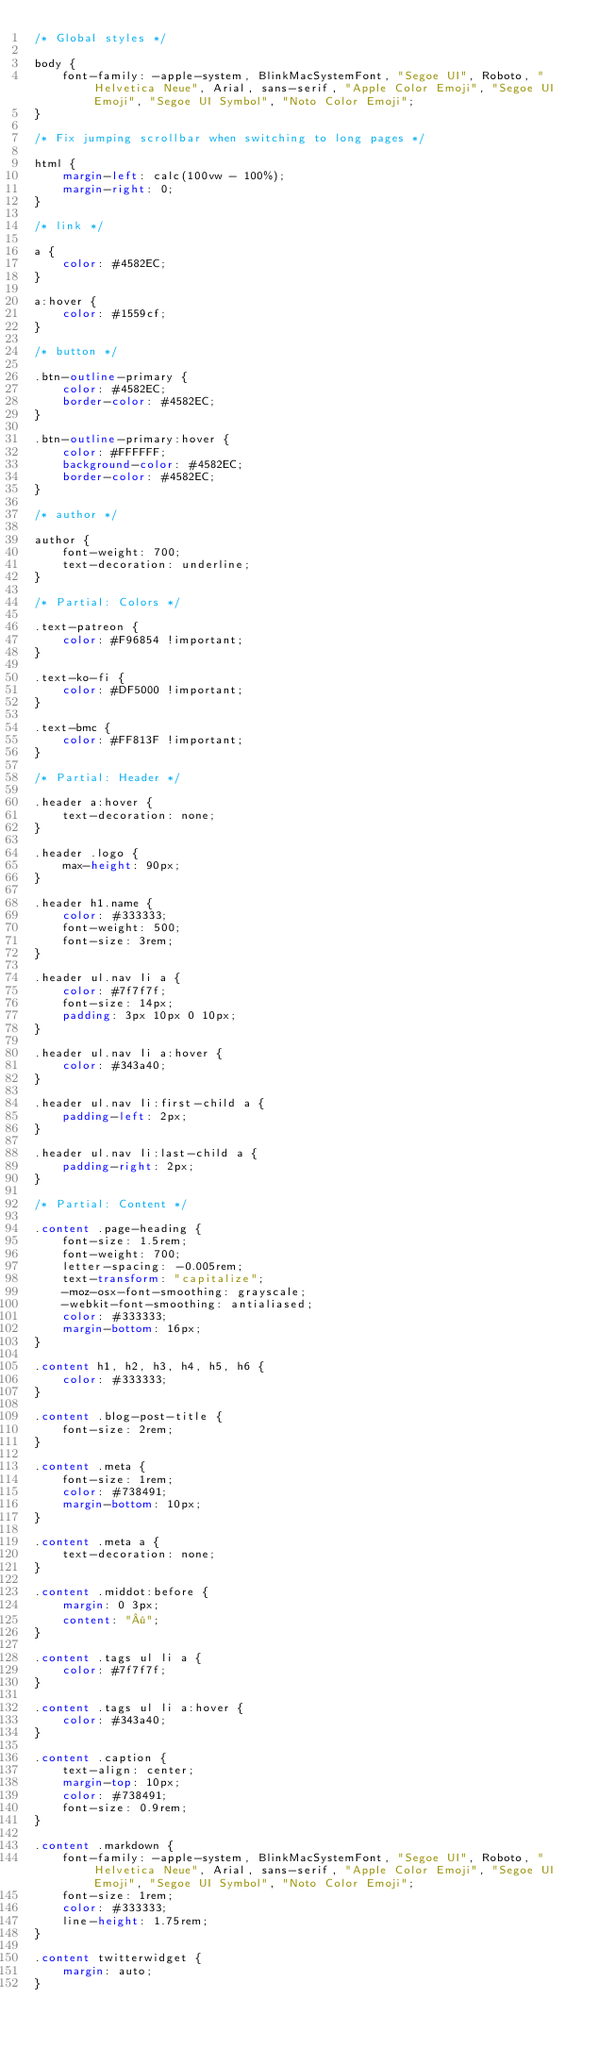<code> <loc_0><loc_0><loc_500><loc_500><_CSS_>/* Global styles */

body {
    font-family: -apple-system, BlinkMacSystemFont, "Segoe UI", Roboto, "Helvetica Neue", Arial, sans-serif, "Apple Color Emoji", "Segoe UI Emoji", "Segoe UI Symbol", "Noto Color Emoji";
}

/* Fix jumping scrollbar when switching to long pages */

html {
    margin-left: calc(100vw - 100%);
    margin-right: 0;
}

/* link */

a {
    color: #4582EC;
}

a:hover {
    color: #1559cf;
}

/* button */

.btn-outline-primary {
    color: #4582EC;
    border-color: #4582EC;
}

.btn-outline-primary:hover {
    color: #FFFFFF;
    background-color: #4582EC;
    border-color: #4582EC;
}

/* author */

author {
    font-weight: 700;
    text-decoration: underline;
}

/* Partial: Colors */

.text-patreon {
    color: #F96854 !important;
}

.text-ko-fi {
    color: #DF5000 !important;
}

.text-bmc {
    color: #FF813F !important;
}

/* Partial: Header */

.header a:hover {
    text-decoration: none;
}

.header .logo {
    max-height: 90px;
}

.header h1.name {
    color: #333333;
    font-weight: 500;
    font-size: 3rem;
}

.header ul.nav li a {
    color: #7f7f7f;
    font-size: 14px;
    padding: 3px 10px 0 10px;
}

.header ul.nav li a:hover {
    color: #343a40;
}

.header ul.nav li:first-child a {
    padding-left: 2px;
}

.header ul.nav li:last-child a {
    padding-right: 2px;
}

/* Partial: Content */

.content .page-heading {
    font-size: 1.5rem;
    font-weight: 700;
    letter-spacing: -0.005rem;
    text-transform: "capitalize";
    -moz-osx-font-smoothing: grayscale;
    -webkit-font-smoothing: antialiased;
    color: #333333;
    margin-bottom: 16px;
}

.content h1, h2, h3, h4, h5, h6 {
    color: #333333;
}

.content .blog-post-title {
    font-size: 2rem;
}

.content .meta {
    font-size: 1rem;
    color: #738491;
    margin-bottom: 10px;
}

.content .meta a {
    text-decoration: none;
}

.content .middot:before {
    margin: 0 3px;
    content: "·";
}

.content .tags ul li a {
    color: #7f7f7f;
}

.content .tags ul li a:hover {
    color: #343a40;
}

.content .caption {
    text-align: center;
    margin-top: 10px;
    color: #738491;
    font-size: 0.9rem;
}

.content .markdown {
    font-family: -apple-system, BlinkMacSystemFont, "Segoe UI", Roboto, "Helvetica Neue", Arial, sans-serif, "Apple Color Emoji", "Segoe UI Emoji", "Segoe UI Symbol", "Noto Color Emoji";
    font-size: 1rem;
    color: #333333;
    line-height: 1.75rem;
}

.content twitterwidget {
    margin: auto;
}
</code> 